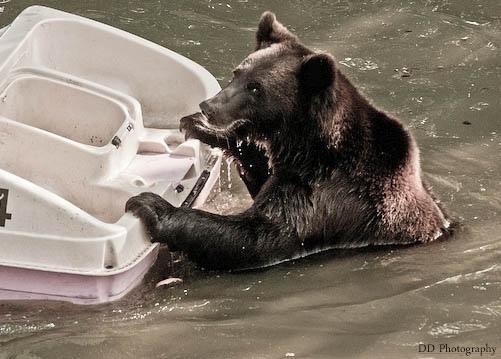Is this bear holding on to stay afloat?
Short answer required. Yes. What is the bear holding on to?
Be succinct. Boat. Is the bear in the water?
Concise answer only. Yes. 